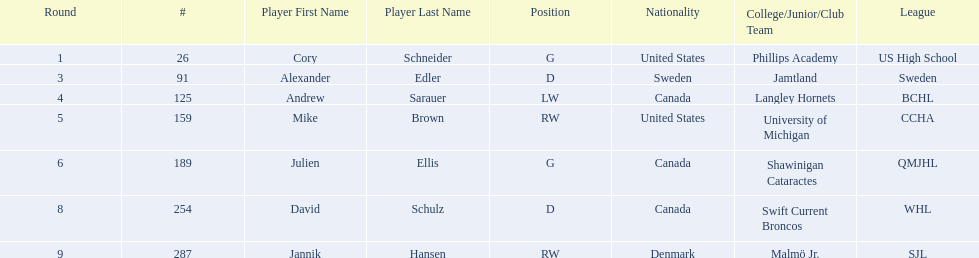What are the nationalities of the players? United States, Sweden, Canada, United States, Canada, Canada, Denmark. Of the players, which one lists his nationality as denmark? Jannik Hansen (RW). Could you parse the entire table? {'header': ['Round', '#', 'Player First Name', 'Player Last Name', 'Position', 'Nationality', 'College/Junior/Club Team', 'League'], 'rows': [['1', '26', 'Cory', 'Schneider', 'G', 'United States', 'Phillips Academy', 'US High School'], ['3', '91', 'Alexander', 'Edler', 'D', 'Sweden', 'Jamtland', 'Sweden'], ['4', '125', 'Andrew', 'Sarauer', 'LW', 'Canada', 'Langley Hornets', 'BCHL'], ['5', '159', 'Mike', 'Brown', 'RW', 'United States', 'University of Michigan', 'CCHA'], ['6', '189', 'Julien', 'Ellis', 'G', 'Canada', 'Shawinigan Cataractes', 'QMJHL'], ['8', '254', 'David', 'Schulz', 'D', 'Canada', 'Swift Current Broncos', 'WHL'], ['9', '287', 'Jannik', 'Hansen', 'RW', 'Denmark', 'Malmö Jr.', 'SJL']]} 